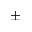<formula> <loc_0><loc_0><loc_500><loc_500>\pm</formula> 